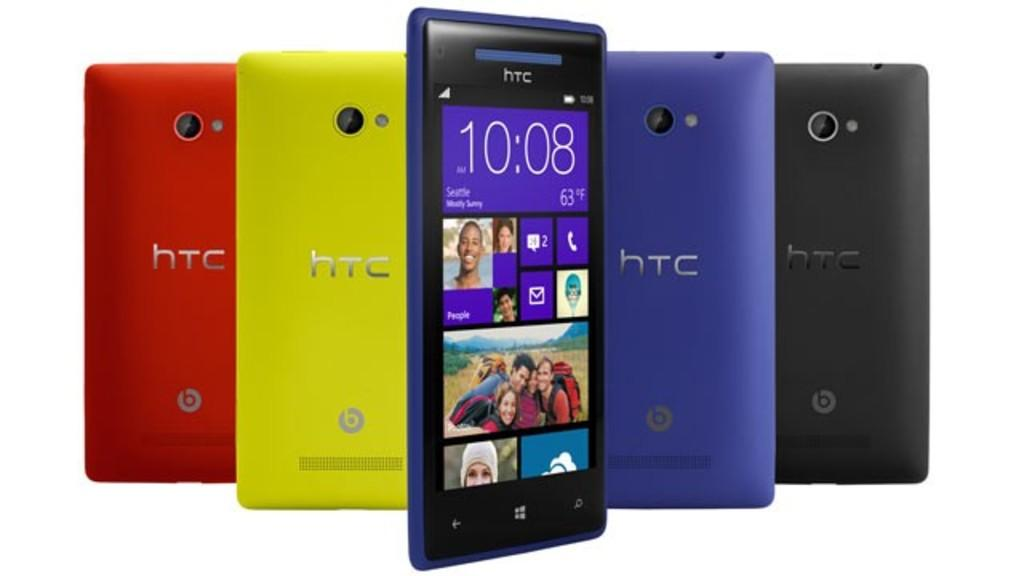<image>
Render a clear and concise summary of the photo. A display of HTC smart phones in multiple colors. 